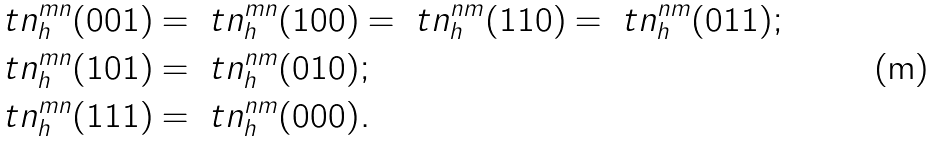Convert formula to latex. <formula><loc_0><loc_0><loc_500><loc_500>\ t n ^ { m n } _ { h } ( 0 0 1 ) & = \ t n ^ { m n } _ { h } ( 1 0 0 ) = \ t n ^ { n m } _ { h } ( 1 1 0 ) = \ t n ^ { n m } _ { h } ( 0 1 1 ) ; \\ \ t n ^ { m n } _ { h } ( 1 0 1 ) & = \ t n ^ { n m } _ { h } ( 0 1 0 ) ; \\ \ t n ^ { m n } _ { h } ( 1 1 1 ) & = \ t n ^ { n m } _ { h } ( 0 0 0 ) .</formula> 